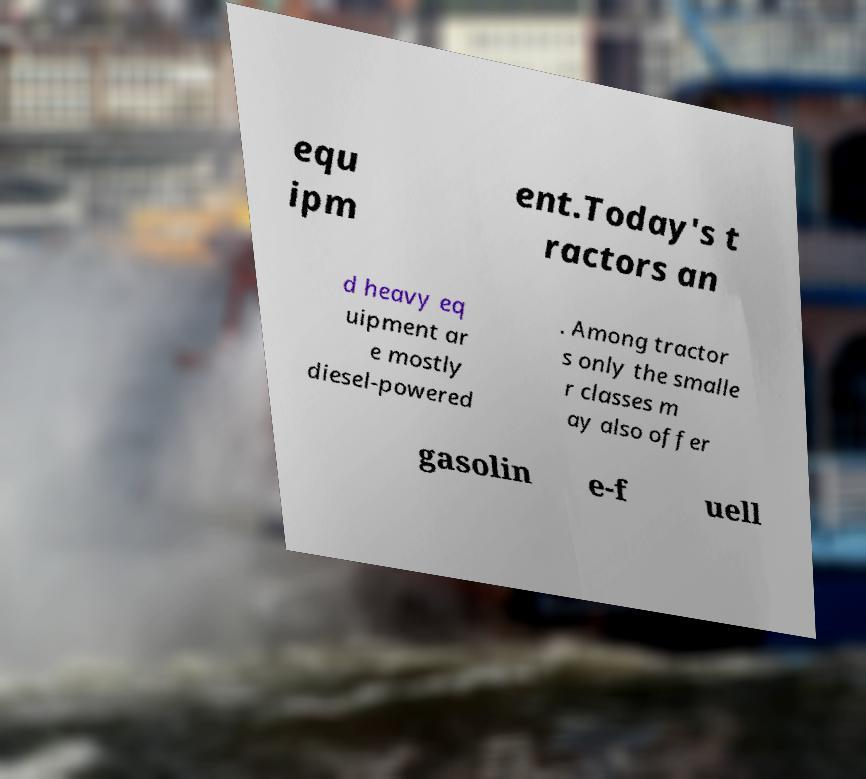There's text embedded in this image that I need extracted. Can you transcribe it verbatim? equ ipm ent.Today's t ractors an d heavy eq uipment ar e mostly diesel-powered . Among tractor s only the smalle r classes m ay also offer gasolin e-f uell 